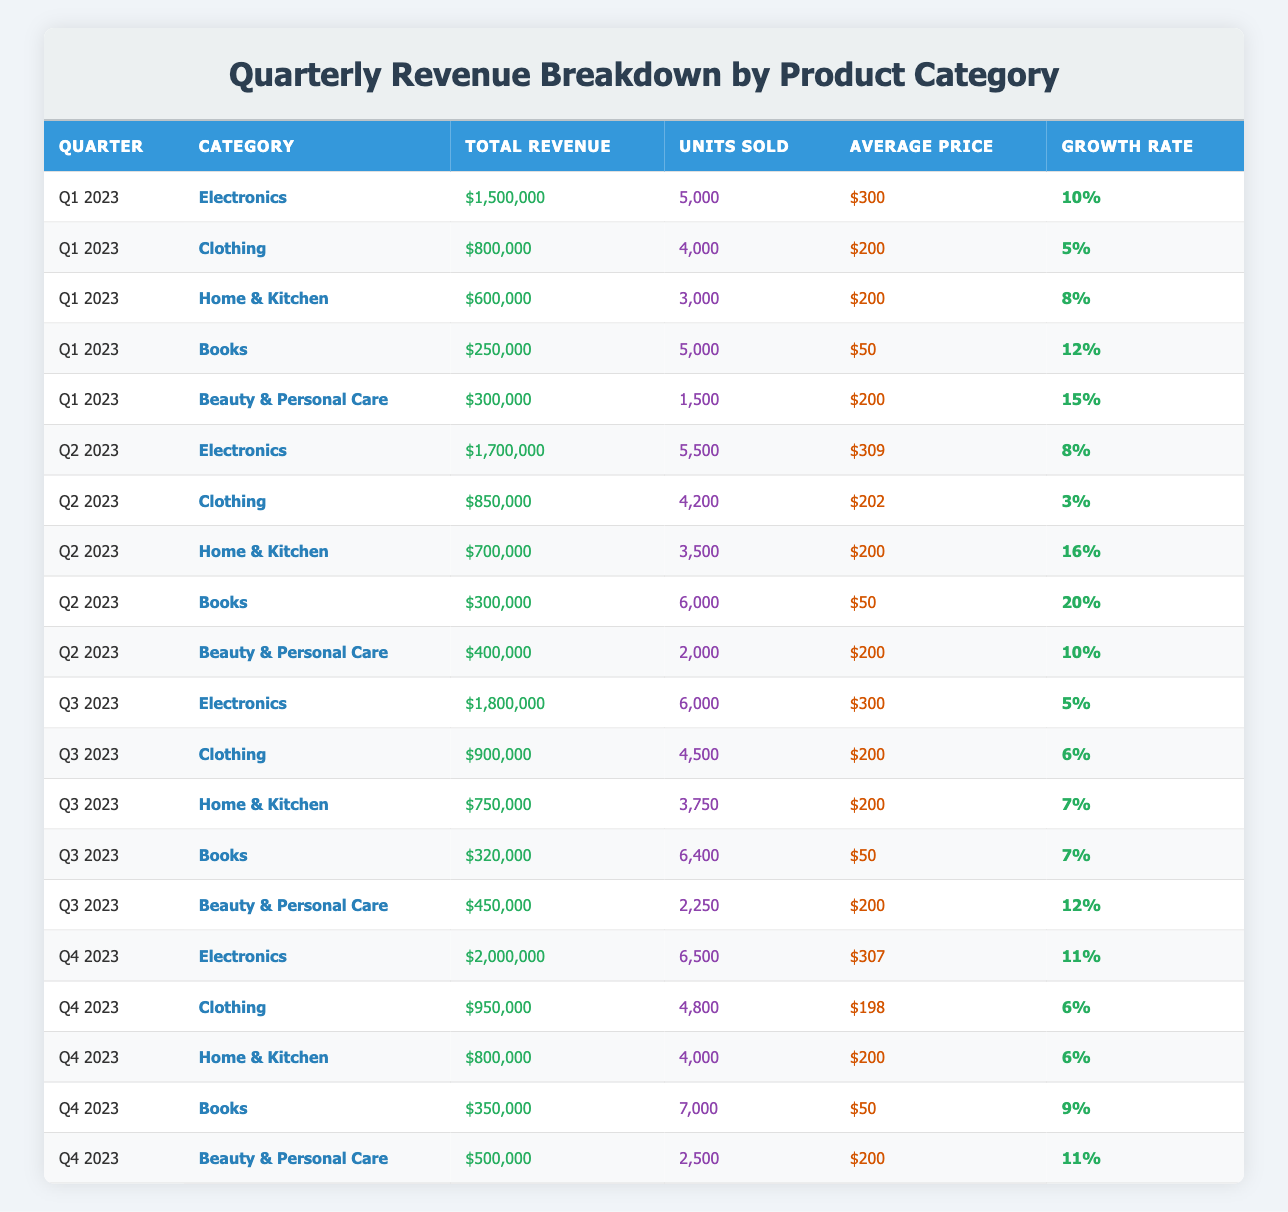What was the total revenue for Electronics in Q2 2023? Looking at the table, the row corresponding to Q2 2023 under the Electronics category shows a total revenue of $1,700,000.
Answer: $1,700,000 How many units of Beauty & Personal Care were sold in Q3 2023? The table indicates that in Q3 2023, the Beauty & Personal Care category had 2,250 units sold.
Answer: 2,250 What is the percentage growth rate for Home & Kitchen from Q1 to Q2 2023? For the Home & Kitchen category, the growth rate in Q1 2023 is 8%, and in Q2 2023 it is 16%. To find the difference, we subtract: 16% - 8% = 8%.
Answer: 8% Is the average price of Clothing higher in Q2 2023 compared to Q1 2023? In Q1 2023, the average price for Clothing is $200, while in Q2 2023 it is $202. Since $202 is greater than $200, the statement is true.
Answer: Yes In Q4 2023, which product category had the highest units sold? The units sold for each category in Q4 2023 are: Electronics 6,500, Clothing 4,800, Home & Kitchen 4,000, Books 7,000, and Beauty & Personal Care 2,500. Since 7,000 units for Books is the highest among them, Books is the answer.
Answer: Books Calculate the total revenue for the Books category across all four quarters. The total revenue for Books is: Q1: $250,000 + Q2: $300,000 + Q3: $320,000 + Q4: $350,000. Adding these together gives: $250,000 + $300,000 + $320,000 + $350,000 = $1,220,000.
Answer: $1,220,000 Did Electronics see an increase in average price from Q2 to Q3 2023? The average price for Electronics in Q2 2023 is $309, and in Q3 2023, it remains at $300. Since $300 is not greater than $309, there was no increase.
Answer: No Which category experienced the highest growth rate in Q2 2023? The table shows the growth rates for each category in Q2 2023: Electronics 8%, Clothing 3%, Home & Kitchen 16%, Books 20%, and Beauty & Personal Care 10%. The highest growth rate is 20% for the Books category.
Answer: Books What is the average revenue for all categories in Q1 2023? The total revenue in Q1 2023 is: Electronics $1,500,000 + Clothing $800,000 + Home & Kitchen $600,000 + Books $250,000 + Beauty & Personal Care $300,000 = $3,450,000. There are 5 categories, so the average is $3,450,000 / 5 = $690,000.
Answer: $690,000 